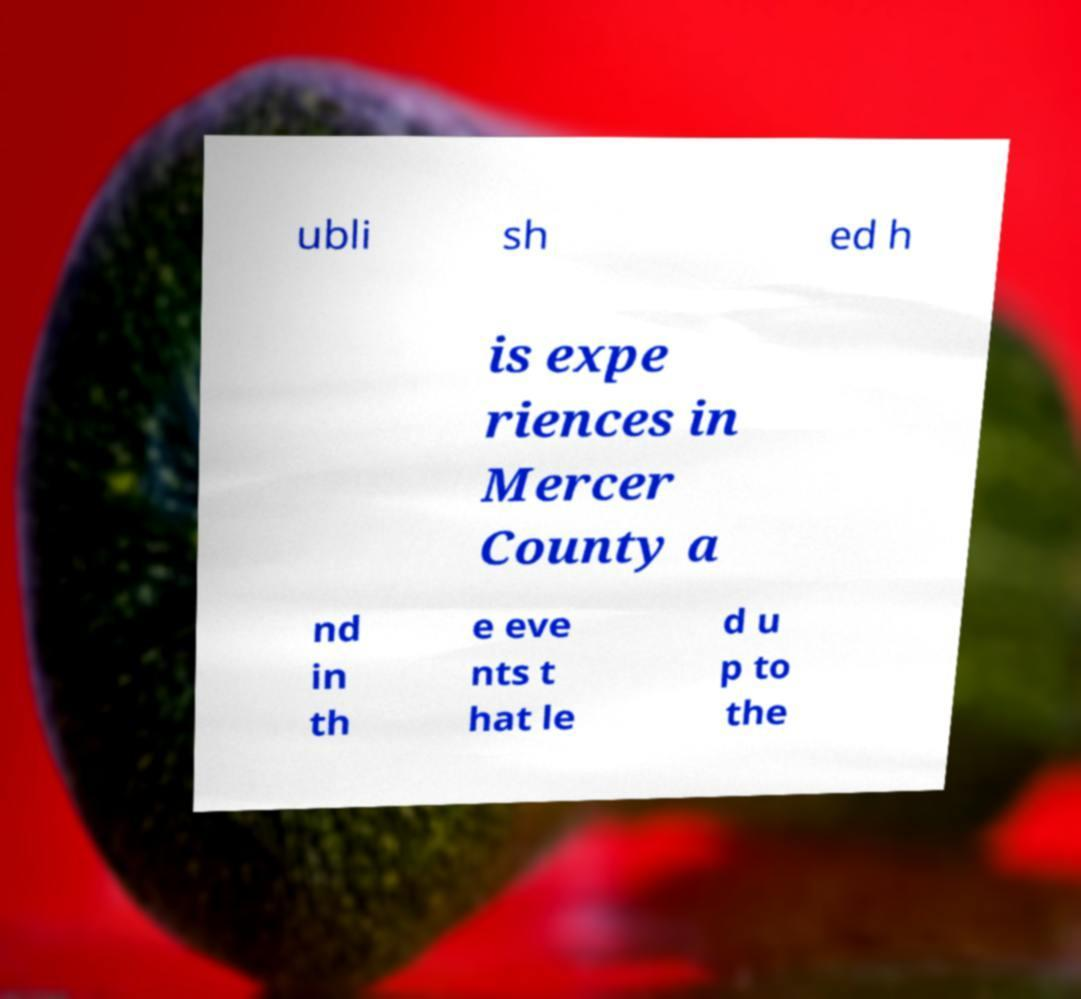For documentation purposes, I need the text within this image transcribed. Could you provide that? ubli sh ed h is expe riences in Mercer County a nd in th e eve nts t hat le d u p to the 